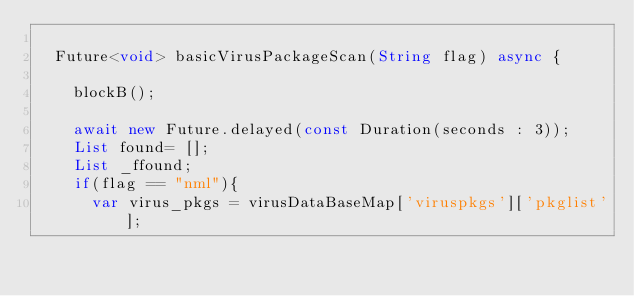Convert code to text. <code><loc_0><loc_0><loc_500><loc_500><_Dart_>
  Future<void> basicVirusPackageScan(String flag) async {

    blockB();

    await new Future.delayed(const Duration(seconds : 3));
    List found= [];
    List _ffound;
    if(flag == "nml"){
      var virus_pkgs = virusDataBaseMap['viruspkgs']['pkglist'];</code> 